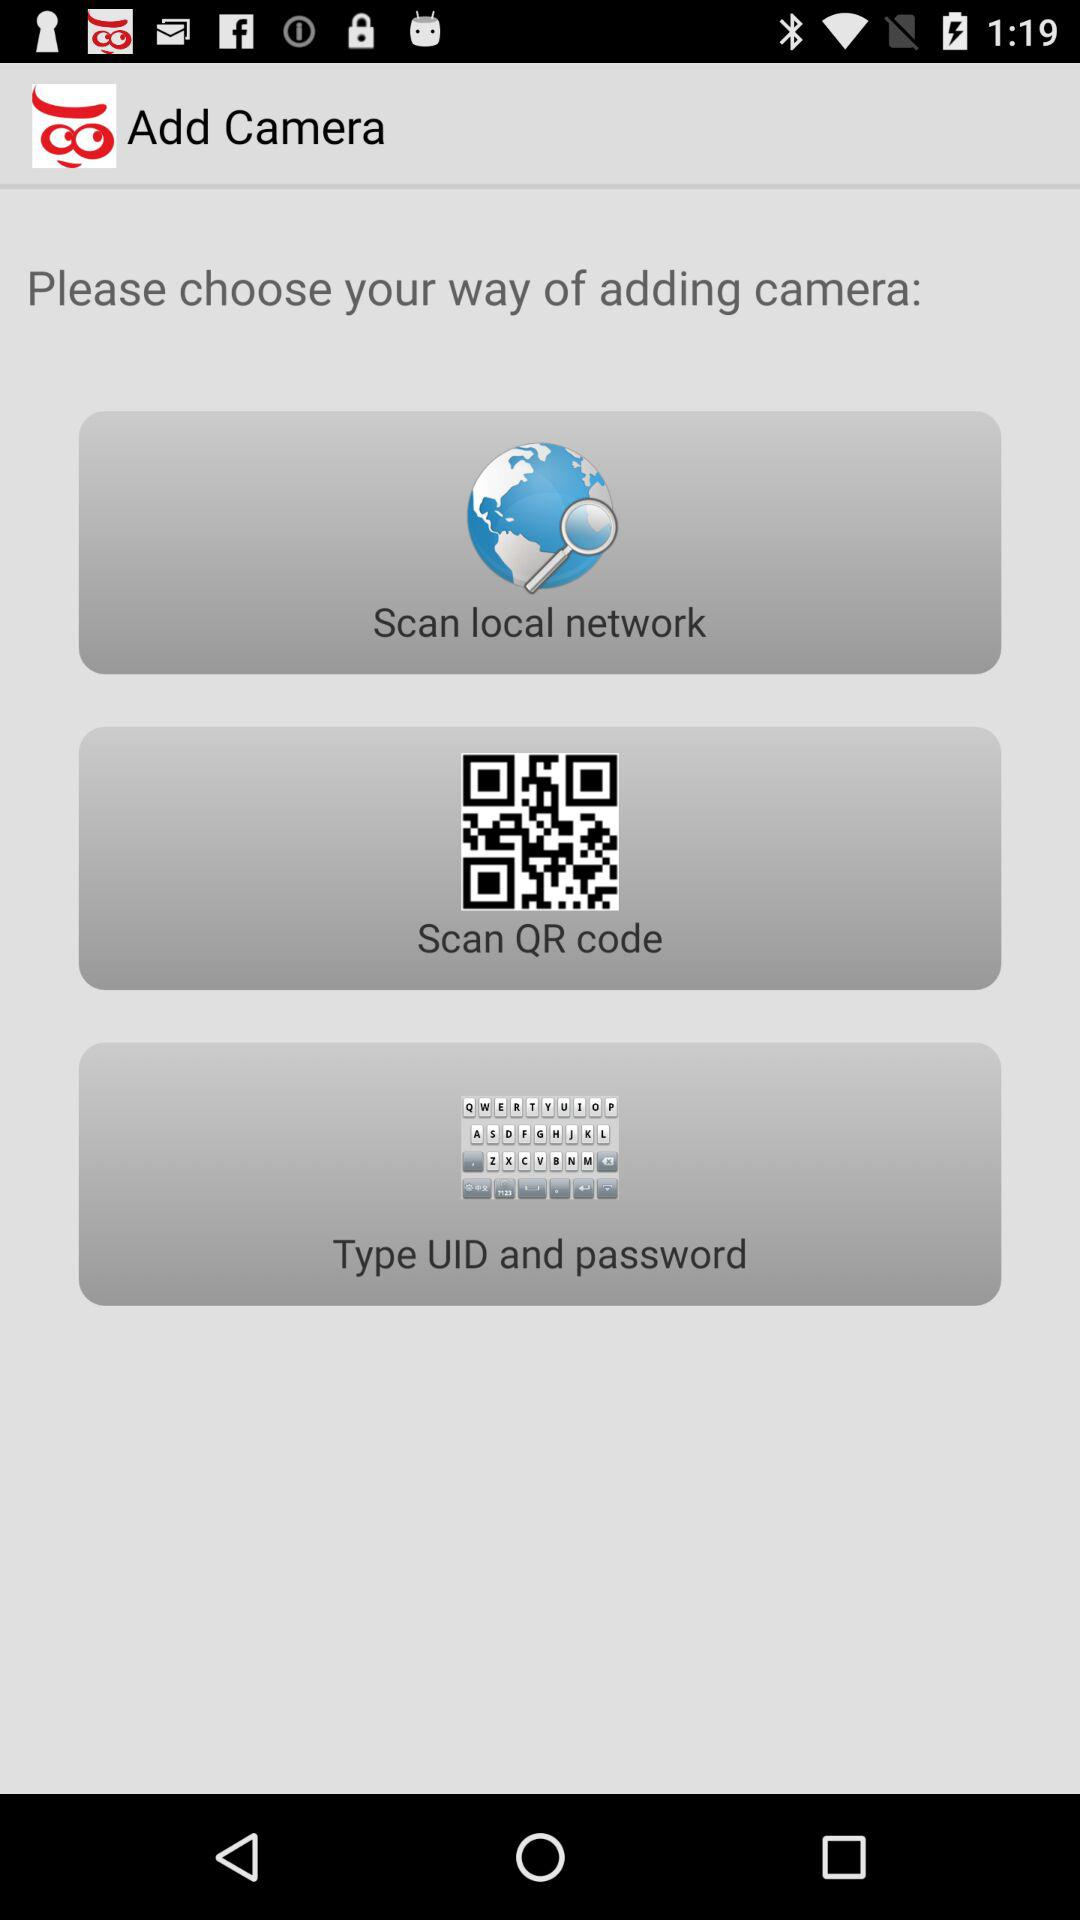What is the way to add a camera? The ways to add a camera are "Scan local network", "Scan QR code" and "Type UID and password". 